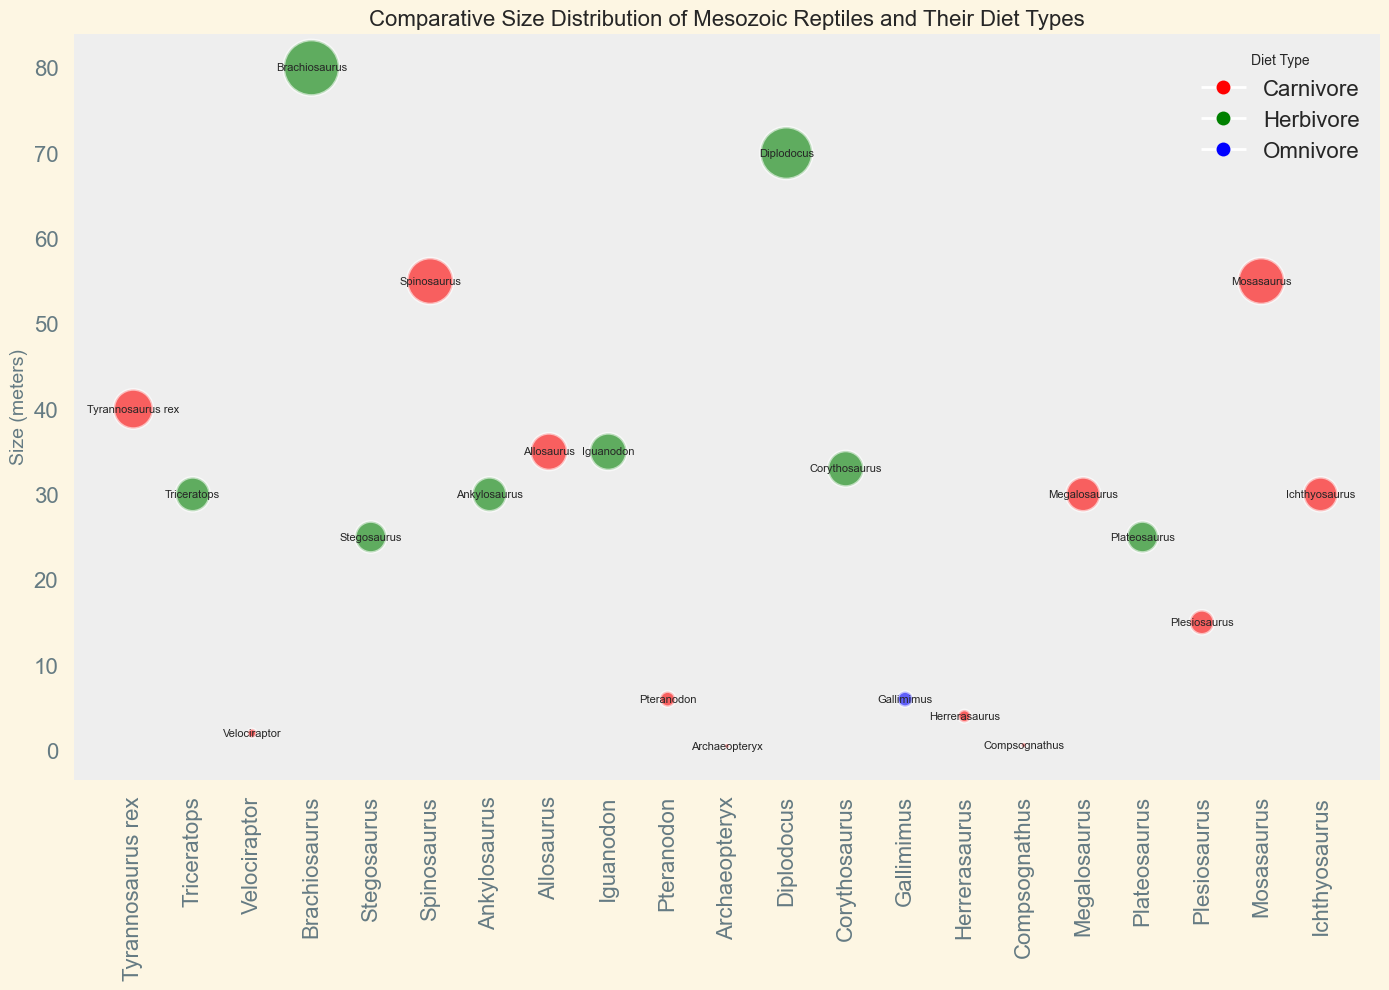Which reptile has the largest size and what is its diet type? The size values are plotted, and the name labels are provided. The largest size is 80 meters, and the corresponding reptile name is Brachiosaurus with a green color indicating it is a Herbivore.
Answer: Brachiosaurus, Herbivore What are the sizes of the three smallest reptiles, and what are their diet types? The smallest size values are 0.5 for Archaeopteryx (Carnivore, red), 0.6 for Compsognathus (Carnivore, red), and 2 for Velociraptor (Carnivore, red).
Answer: 0.5 (Archaeopteryx, Carnivore), 0.6 (Compsognathus, Carnivore), 2 (Velociraptor, Carnivore) Compare the sizes of Spinosaurus and Tyrannosaurus rex. Which one is larger and by how much? Spinosaurus has a size of 55 meters while Tyrannosaurus rex is 40 meters. The difference is 55 - 40 = 15 meters, so Spinosaurus is larger by 15 meters.
Answer: Spinosaurus, 15 meters What is the average size of all Herbivore reptiles? The sizes of the Herbivores are 30, 30, 80, 25, 35, 70, 33, and 25. The total sum is 328, and there are 8 Herbivores. Thus, the average size is 328 / 8 = 41 meters.
Answer: 41 meters Which reptiles are both Carnivores and have a similar size to Allosaurus? Allosaurus has a size of 35 meters. The Carnivores with similar sizes around 35 meters are Tyrannosaurus rex (40 meters) and Spinosaurus (55 meters); however, the closest in size is Tyrannosaurus rex.
Answer: Tyrannosaurus rex Which Omnivore reptile is shown in the figure, and what is its size? There is only one blue-colored data point indicating an Omnivore diet, identified as Gallimimus with a size of 6 meters.
Answer: Gallimimus, 6 meters 